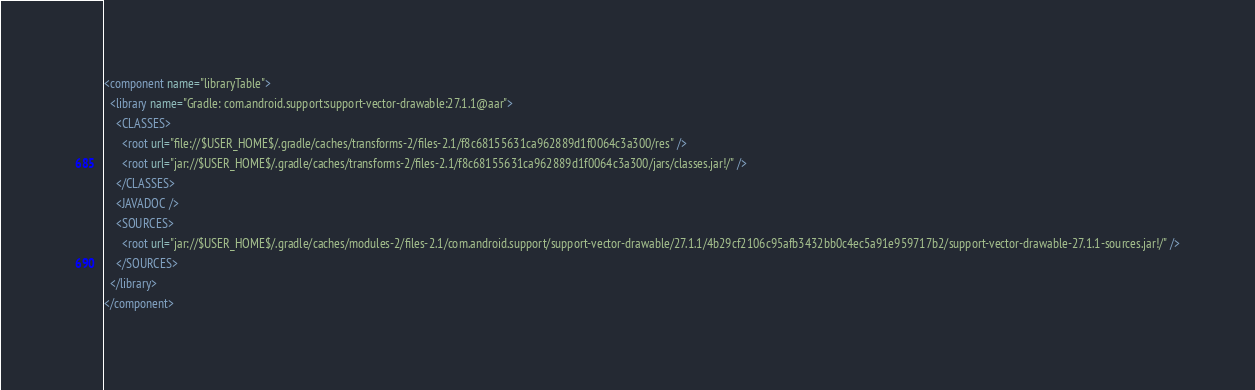<code> <loc_0><loc_0><loc_500><loc_500><_XML_><component name="libraryTable">
  <library name="Gradle: com.android.support:support-vector-drawable:27.1.1@aar">
    <CLASSES>
      <root url="file://$USER_HOME$/.gradle/caches/transforms-2/files-2.1/f8c68155631ca962889d1f0064c3a300/res" />
      <root url="jar://$USER_HOME$/.gradle/caches/transforms-2/files-2.1/f8c68155631ca962889d1f0064c3a300/jars/classes.jar!/" />
    </CLASSES>
    <JAVADOC />
    <SOURCES>
      <root url="jar://$USER_HOME$/.gradle/caches/modules-2/files-2.1/com.android.support/support-vector-drawable/27.1.1/4b29cf2106c95afb3432bb0c4ec5a91e959717b2/support-vector-drawable-27.1.1-sources.jar!/" />
    </SOURCES>
  </library>
</component></code> 